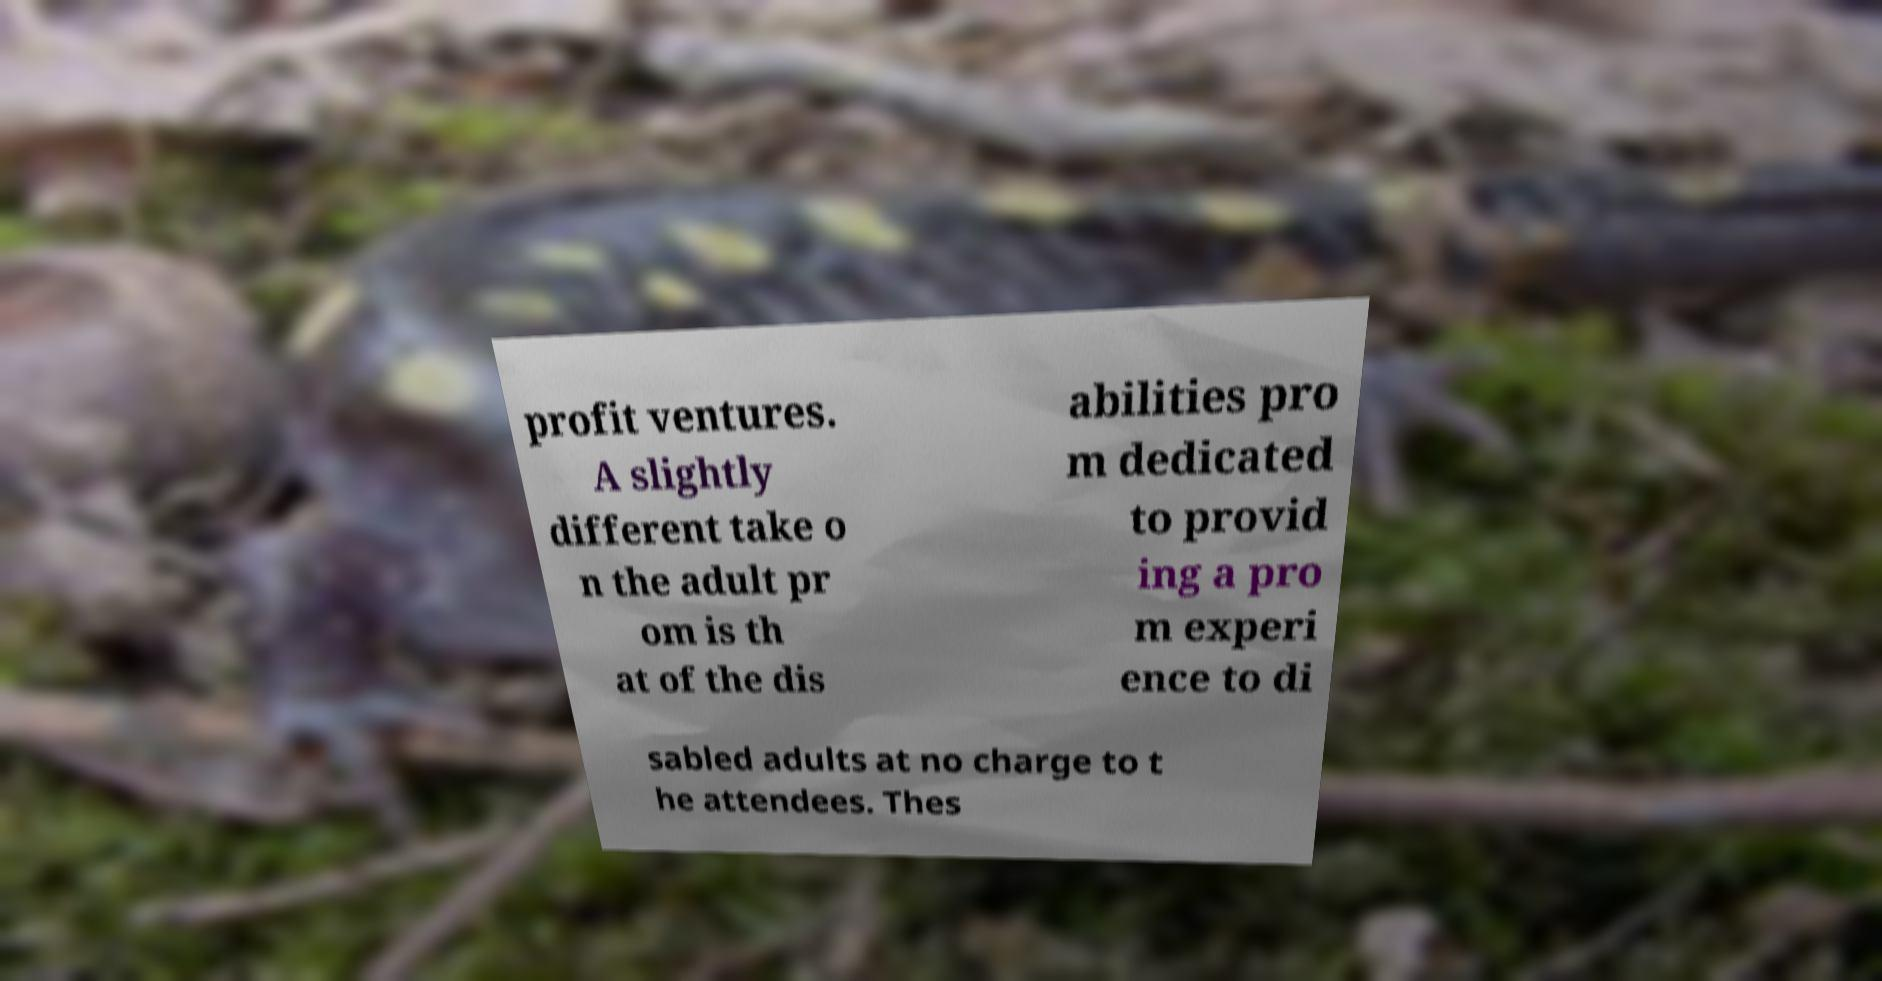Please identify and transcribe the text found in this image. profit ventures. A slightly different take o n the adult pr om is th at of the dis abilities pro m dedicated to provid ing a pro m experi ence to di sabled adults at no charge to t he attendees. Thes 